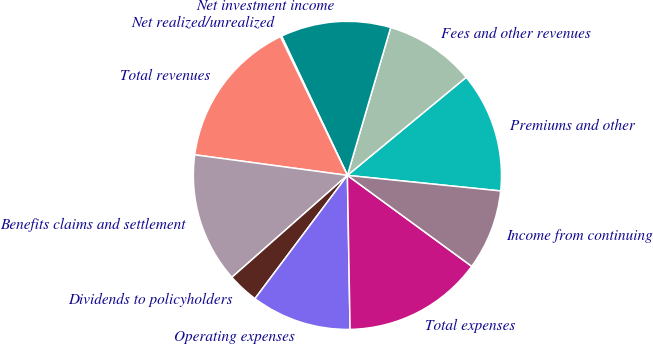<chart> <loc_0><loc_0><loc_500><loc_500><pie_chart><fcel>Premiums and other<fcel>Fees and other revenues<fcel>Net investment income<fcel>Net realized/unrealized<fcel>Total revenues<fcel>Benefits claims and settlement<fcel>Dividends to policyholders<fcel>Operating expenses<fcel>Total expenses<fcel>Income from continuing<nl><fcel>12.6%<fcel>9.48%<fcel>11.56%<fcel>0.13%<fcel>15.71%<fcel>13.64%<fcel>3.25%<fcel>10.52%<fcel>14.67%<fcel>8.44%<nl></chart> 